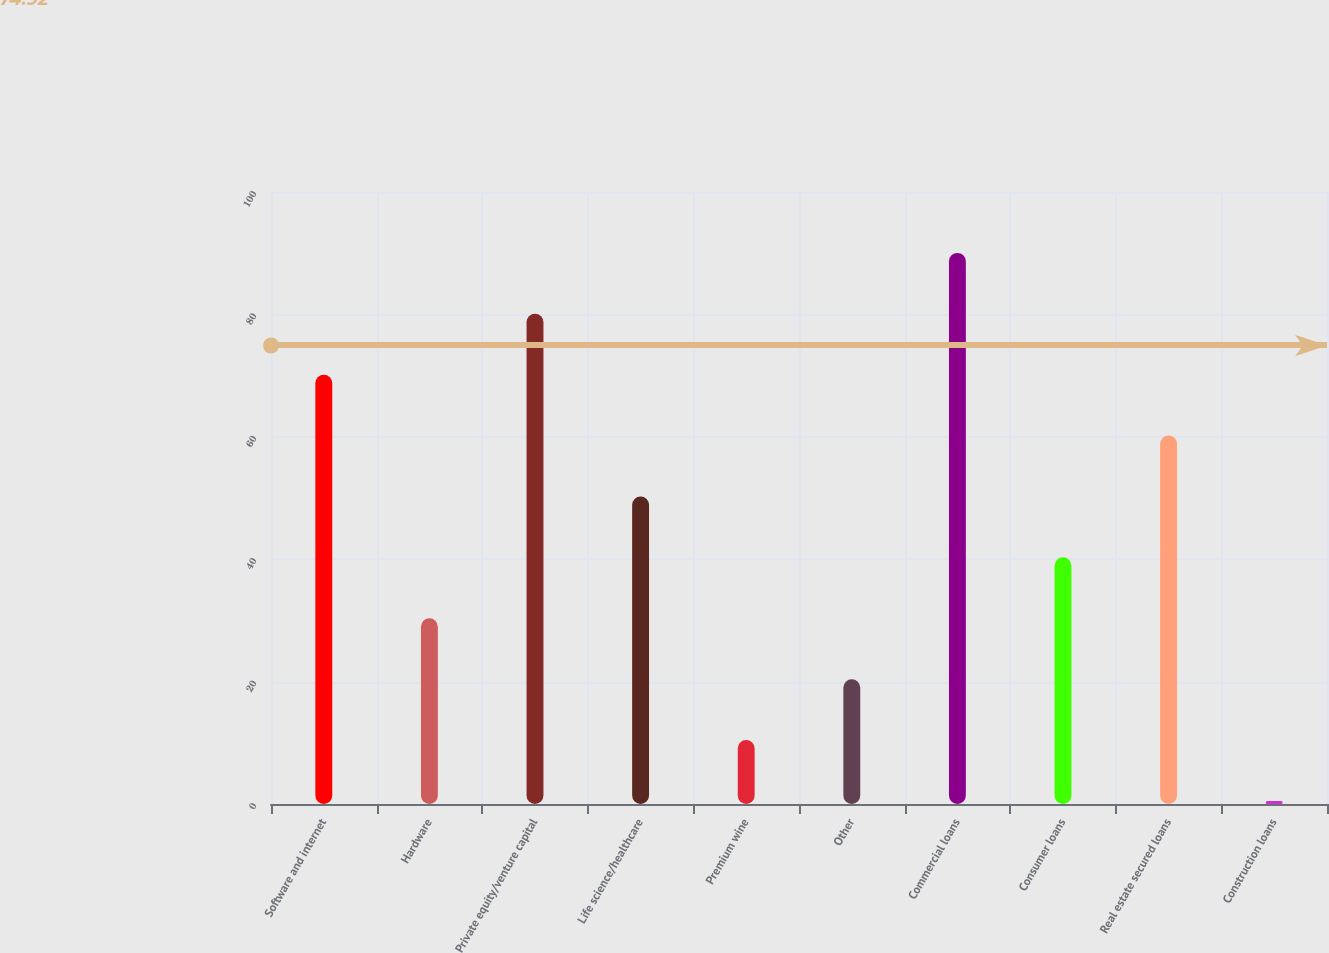Convert chart to OTSL. <chart><loc_0><loc_0><loc_500><loc_500><bar_chart><fcel>Software and internet<fcel>Hardware<fcel>Private equity/venture capital<fcel>Life science/healthcare<fcel>Premium wine<fcel>Other<fcel>Commercial loans<fcel>Consumer loans<fcel>Real estate secured loans<fcel>Construction loans<nl><fcel>70.15<fcel>30.35<fcel>80.1<fcel>50.25<fcel>10.45<fcel>20.4<fcel>90.05<fcel>40.3<fcel>60.2<fcel>0.5<nl></chart> 